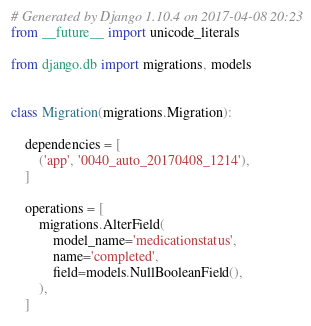<code> <loc_0><loc_0><loc_500><loc_500><_Python_># Generated by Django 1.10.4 on 2017-04-08 20:23
from __future__ import unicode_literals

from django.db import migrations, models


class Migration(migrations.Migration):

    dependencies = [
        ('app', '0040_auto_20170408_1214'),
    ]

    operations = [
        migrations.AlterField(
            model_name='medicationstatus',
            name='completed',
            field=models.NullBooleanField(),
        ),
    ]
</code> 